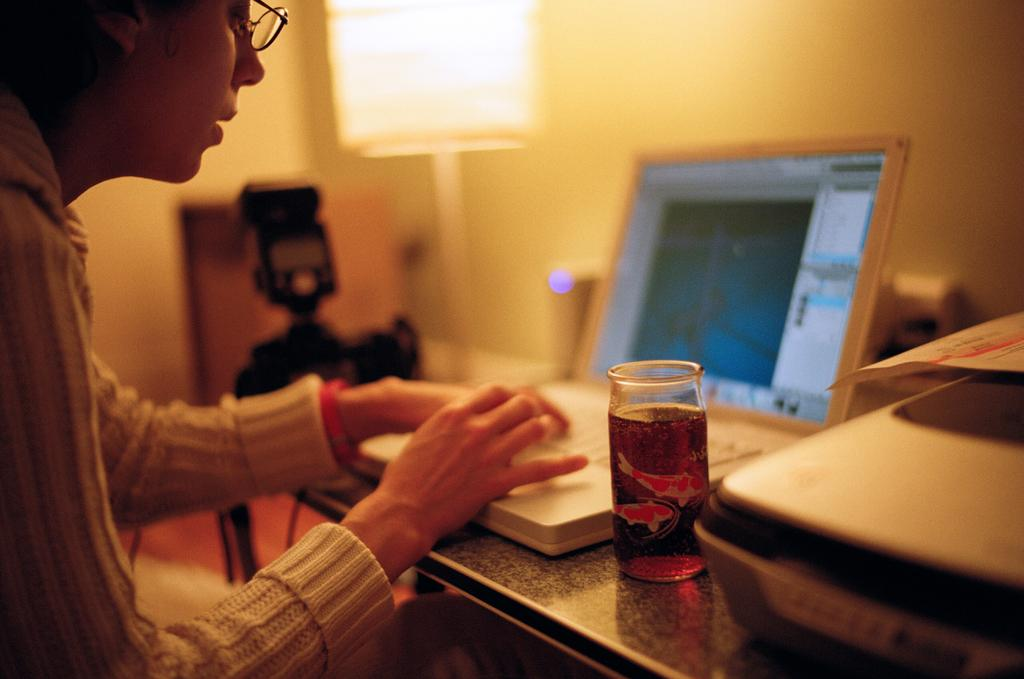Who is the person in the image? There is a woman in the image. What is the woman doing in the image? The woman is working on a laptop. What objects can be seen on the table in the image? There is a glass, a box, and a paper on the table. What device is visible on the side of the image? There is a camera on the side. What type of lighting is present in the image? There is a stand light in the image. What year is depicted in the image? The image does not depict a specific year; it is a snapshot of a woman working on a laptop and the surrounding objects. 